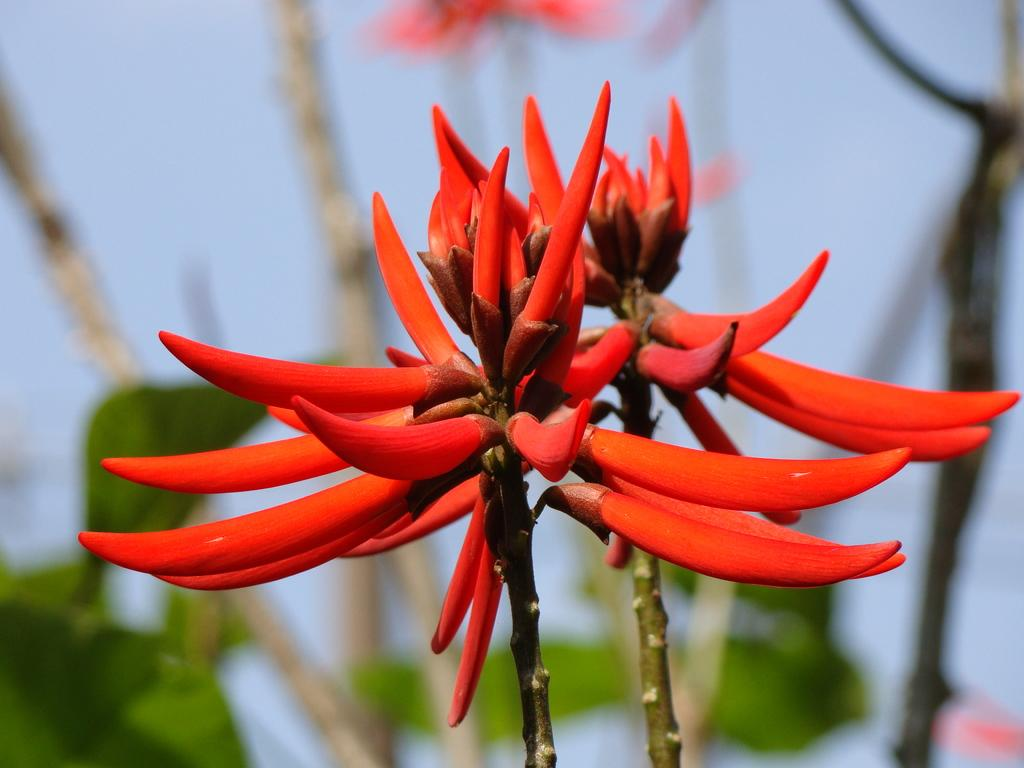What type of plants can be seen in the image? There are flowers in the image. What color are the flowers? The flowers are red. What else can be seen in the background of the image? There are leaves in the background of the image. What is visible at the top of the image? The sky is visible at the top of the image. How is the background of the image depicted? The background is blurred. What hobbies do the cats in the image enjoy? There are no cats present in the image, so we cannot determine their hobbies. 